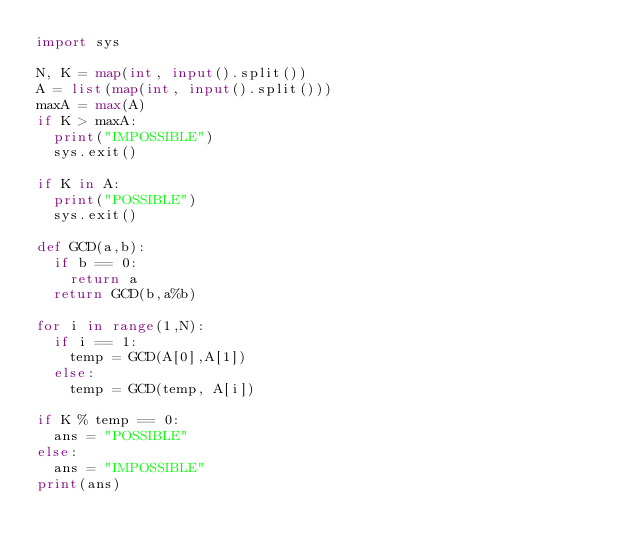Convert code to text. <code><loc_0><loc_0><loc_500><loc_500><_Python_>import sys

N, K = map(int, input().split())
A = list(map(int, input().split()))
maxA = max(A)
if K > maxA:
	print("IMPOSSIBLE")
	sys.exit()

if K in A:
	print("POSSIBLE")
	sys.exit()

def GCD(a,b):
	if b == 0:
		return a
	return GCD(b,a%b)

for i in range(1,N):
	if i == 1:
		temp = GCD(A[0],A[1])
	else:
		temp = GCD(temp, A[i])

if K % temp == 0:
	ans = "POSSIBLE"
else:
	ans = "IMPOSSIBLE"
print(ans)
</code> 